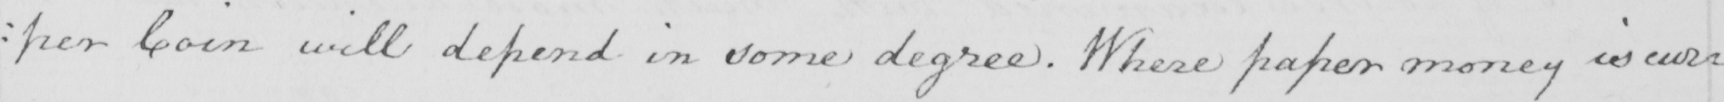What text is written in this handwritten line? : per Coin will depend in some degree . Where paper money is cur= 